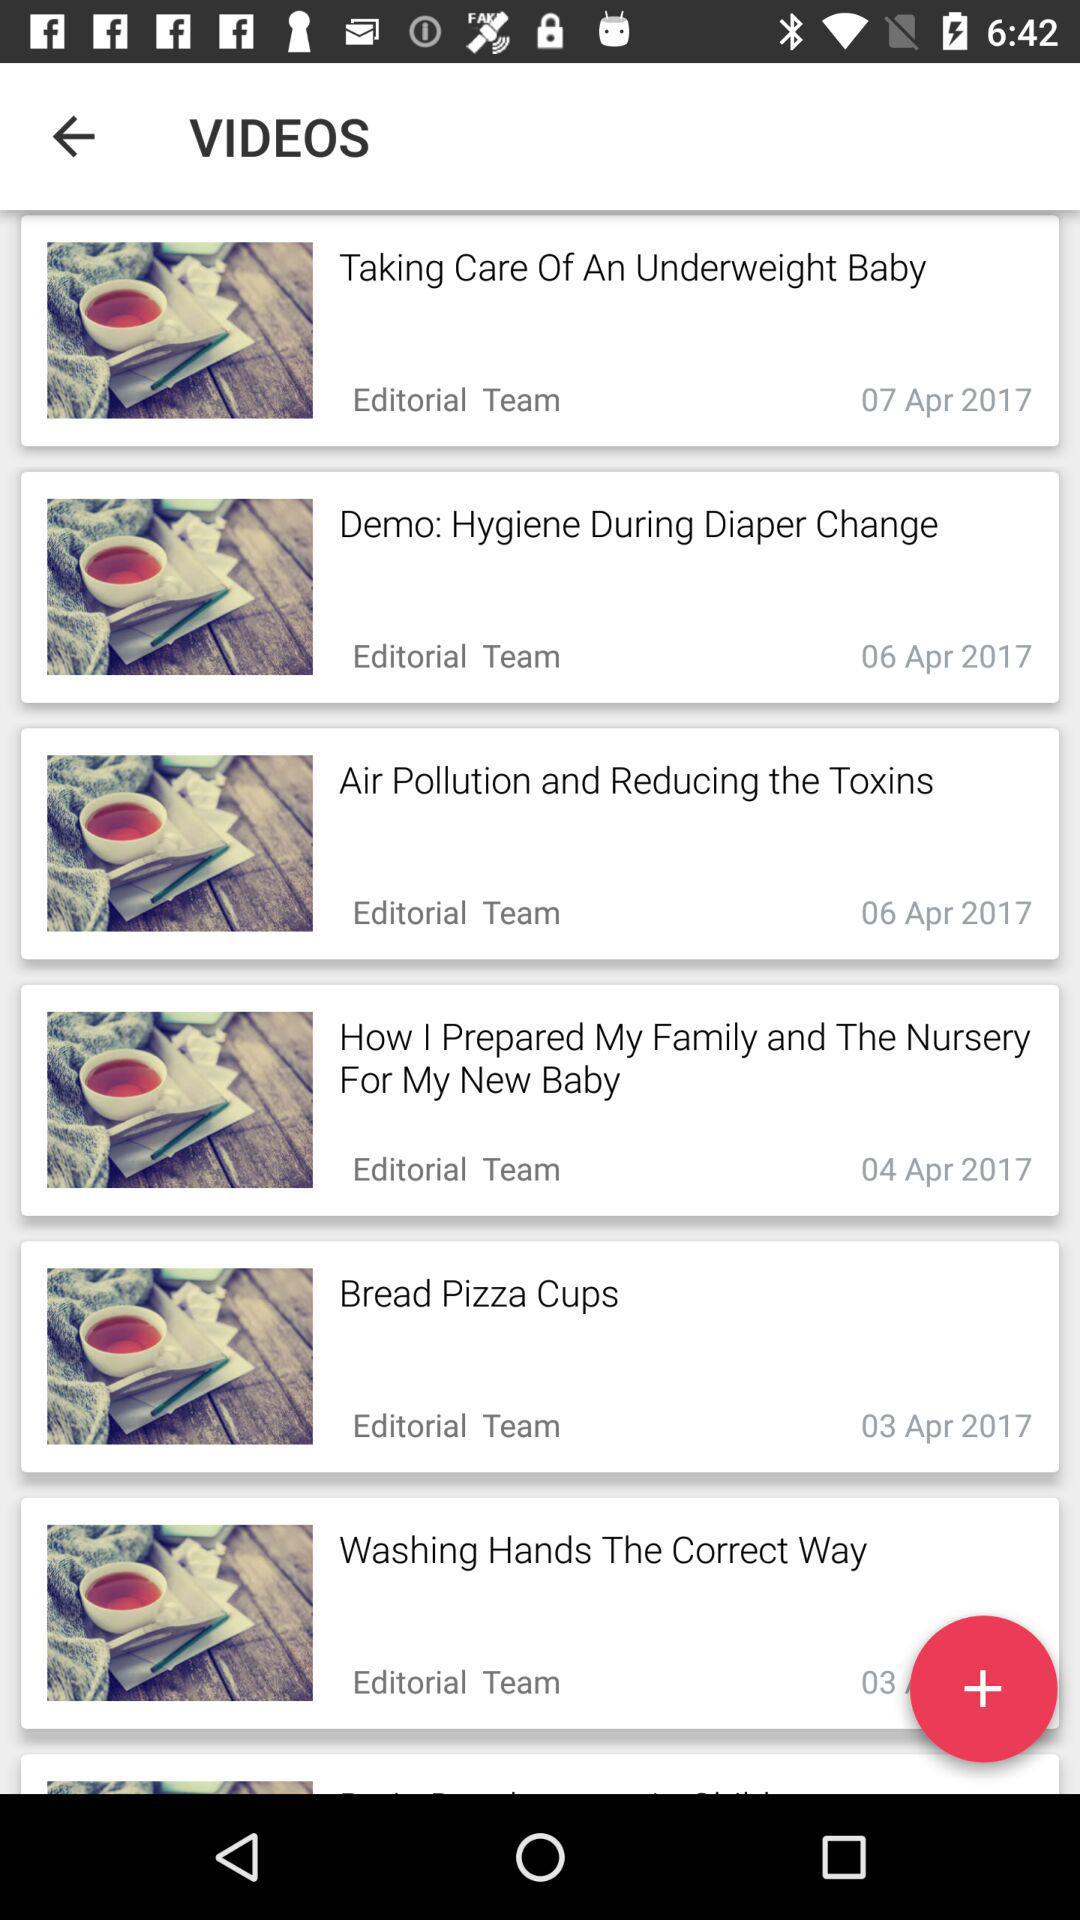When was the video posted titled "Air Pollution and Reducing the Toxins"? The video was posted on April 6, 2017. 